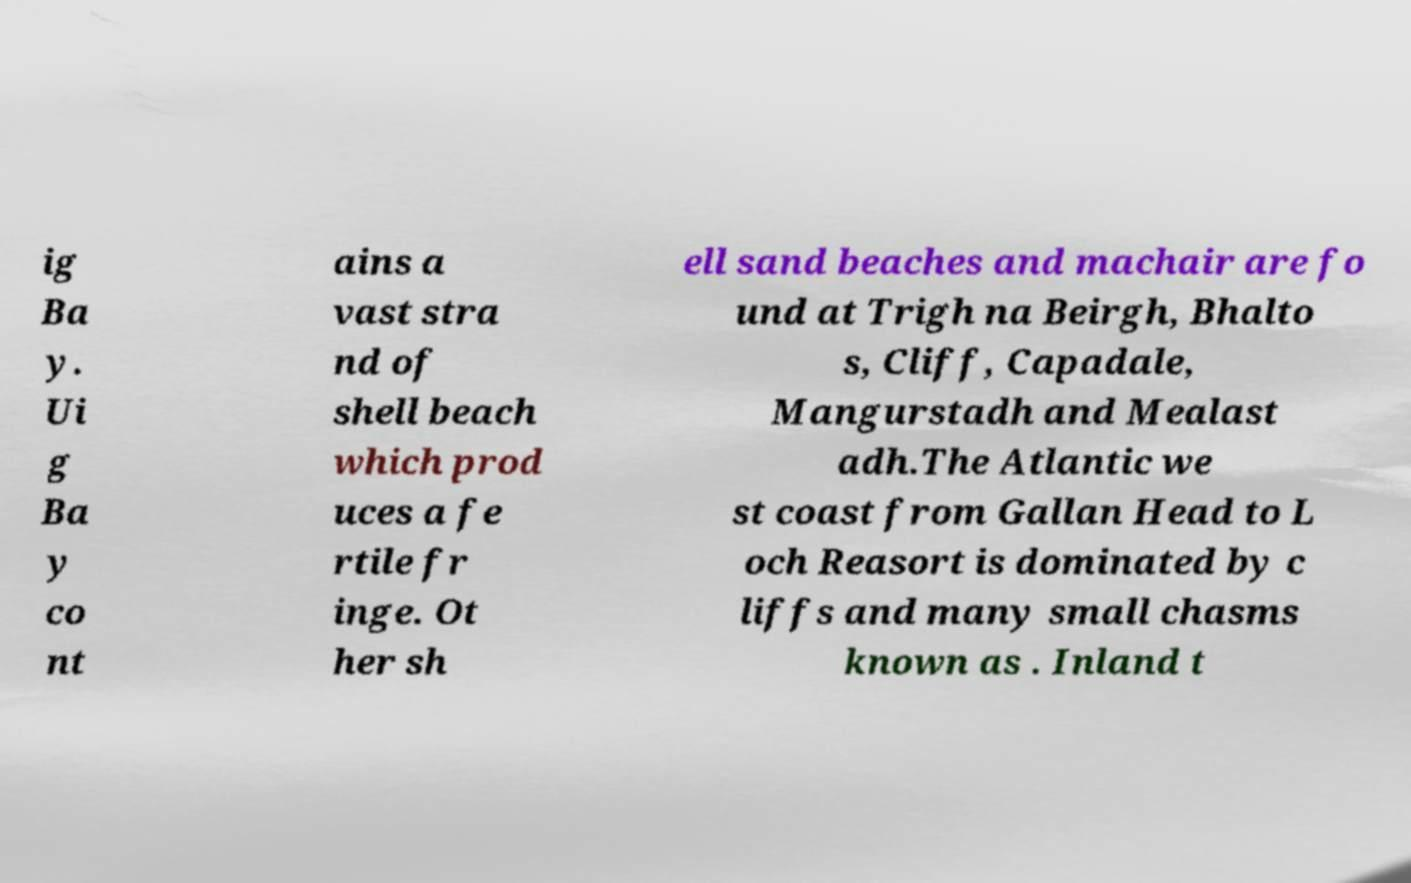Can you read and provide the text displayed in the image?This photo seems to have some interesting text. Can you extract and type it out for me? ig Ba y. Ui g Ba y co nt ains a vast stra nd of shell beach which prod uces a fe rtile fr inge. Ot her sh ell sand beaches and machair are fo und at Trigh na Beirgh, Bhalto s, Cliff, Capadale, Mangurstadh and Mealast adh.The Atlantic we st coast from Gallan Head to L och Reasort is dominated by c liffs and many small chasms known as . Inland t 